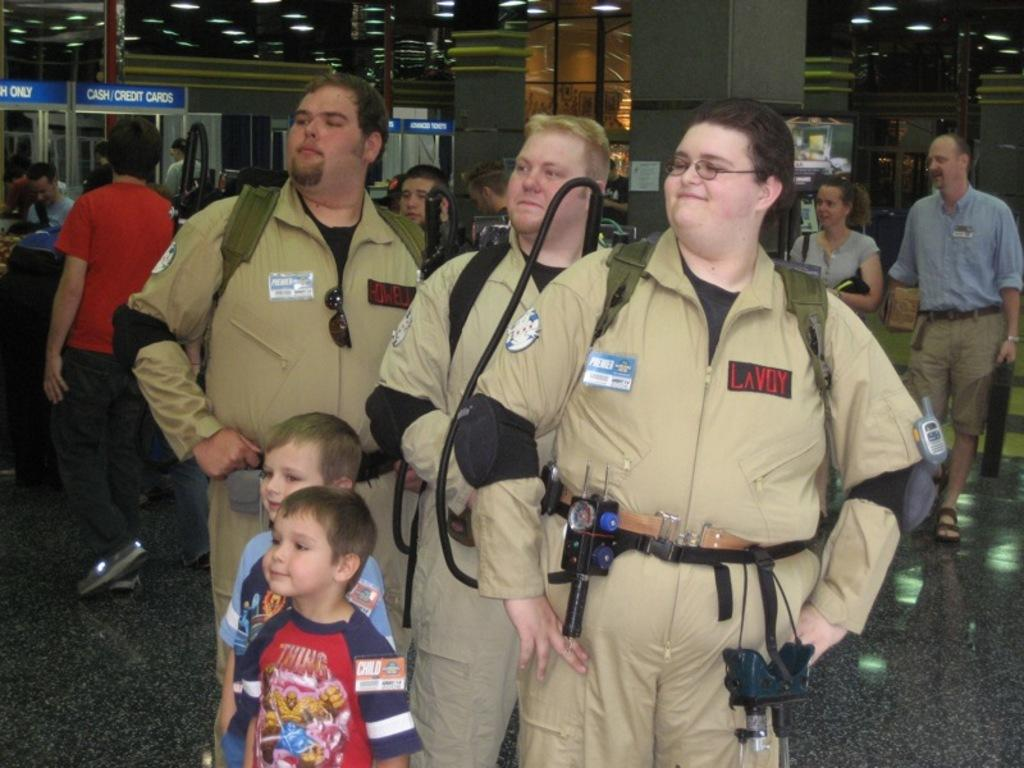Who or what can be seen in the image? There are people in the image. What architectural features are present in the image? There are pillars in the image. What can be seen providing illumination in the image? There are lights in the image. What type of signage or display is present in the image? There are boards in the image. Can you describe any other objects or elements in the image? There are unspecified objects in the image. What type of fork can be seen in the position shown in the image? There is no fork present in the image. 